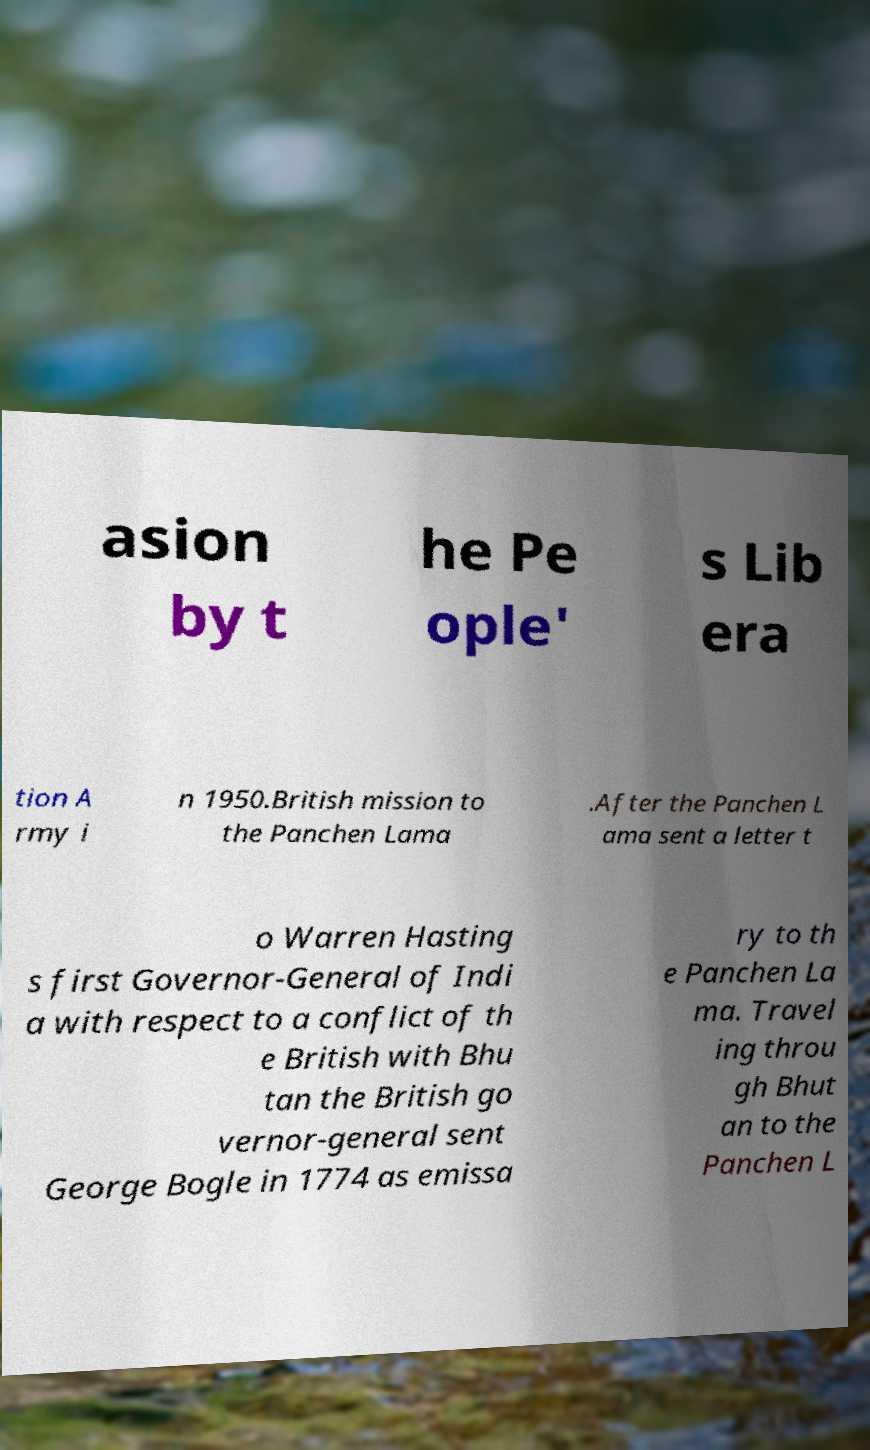Please identify and transcribe the text found in this image. asion by t he Pe ople' s Lib era tion A rmy i n 1950.British mission to the Panchen Lama .After the Panchen L ama sent a letter t o Warren Hasting s first Governor-General of Indi a with respect to a conflict of th e British with Bhu tan the British go vernor-general sent George Bogle in 1774 as emissa ry to th e Panchen La ma. Travel ing throu gh Bhut an to the Panchen L 